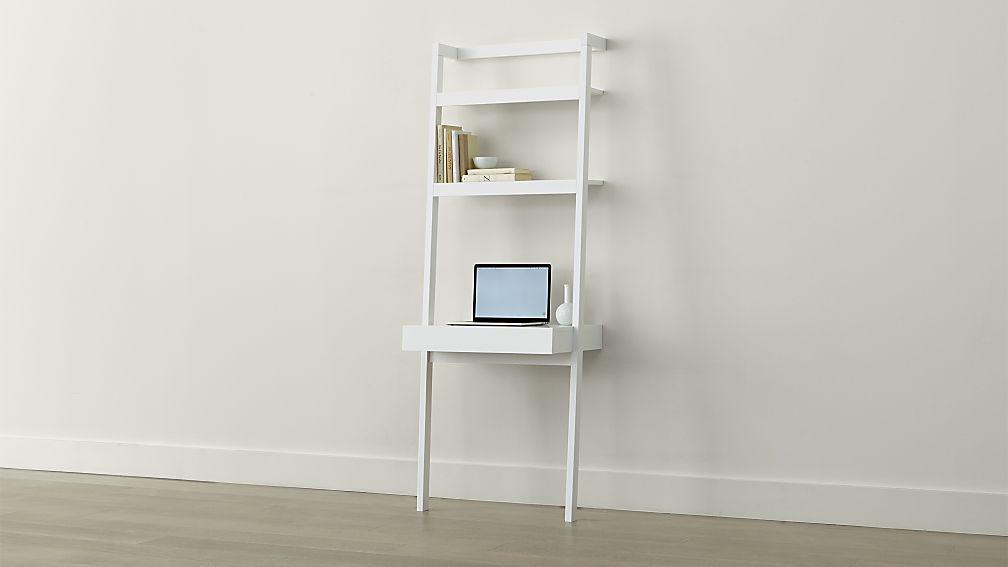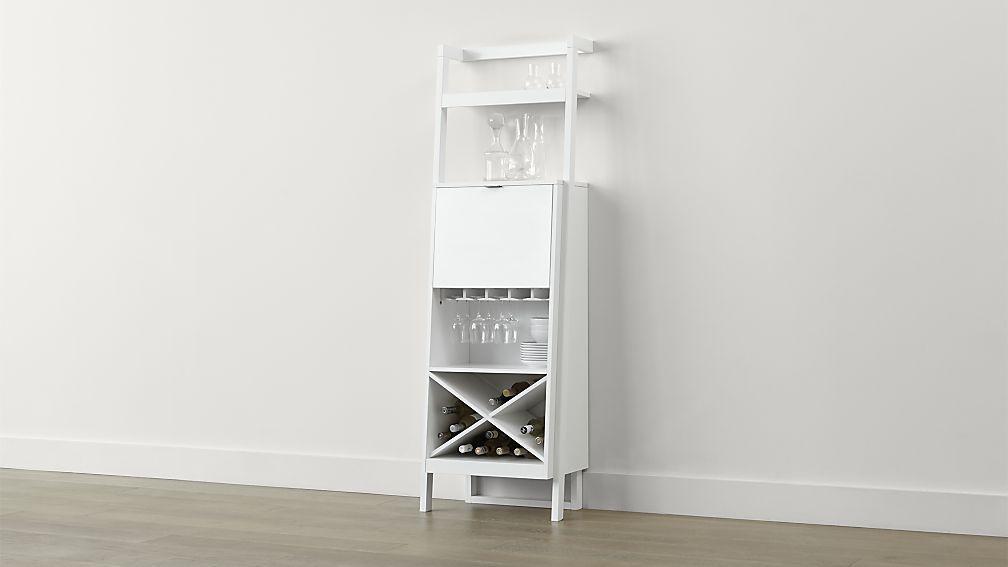The first image is the image on the left, the second image is the image on the right. Considering the images on both sides, is "There us a white bookshelf with a laptop on it ,  a stack of books with a bowl on top of another stack of books are on the shelf above the laptop" valid? Answer yes or no. Yes. The first image is the image on the left, the second image is the image on the right. For the images shown, is this caption "In one image, a bookshelf has three vertical shelf sections with a computer placed in the center unit." true? Answer yes or no. No. 